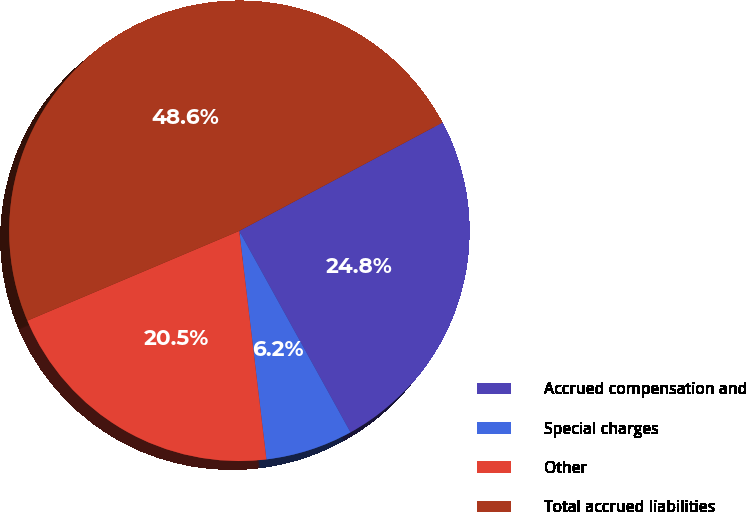Convert chart. <chart><loc_0><loc_0><loc_500><loc_500><pie_chart><fcel>Accrued compensation and<fcel>Special charges<fcel>Other<fcel>Total accrued liabilities<nl><fcel>24.76%<fcel>6.15%<fcel>20.51%<fcel>48.58%<nl></chart> 